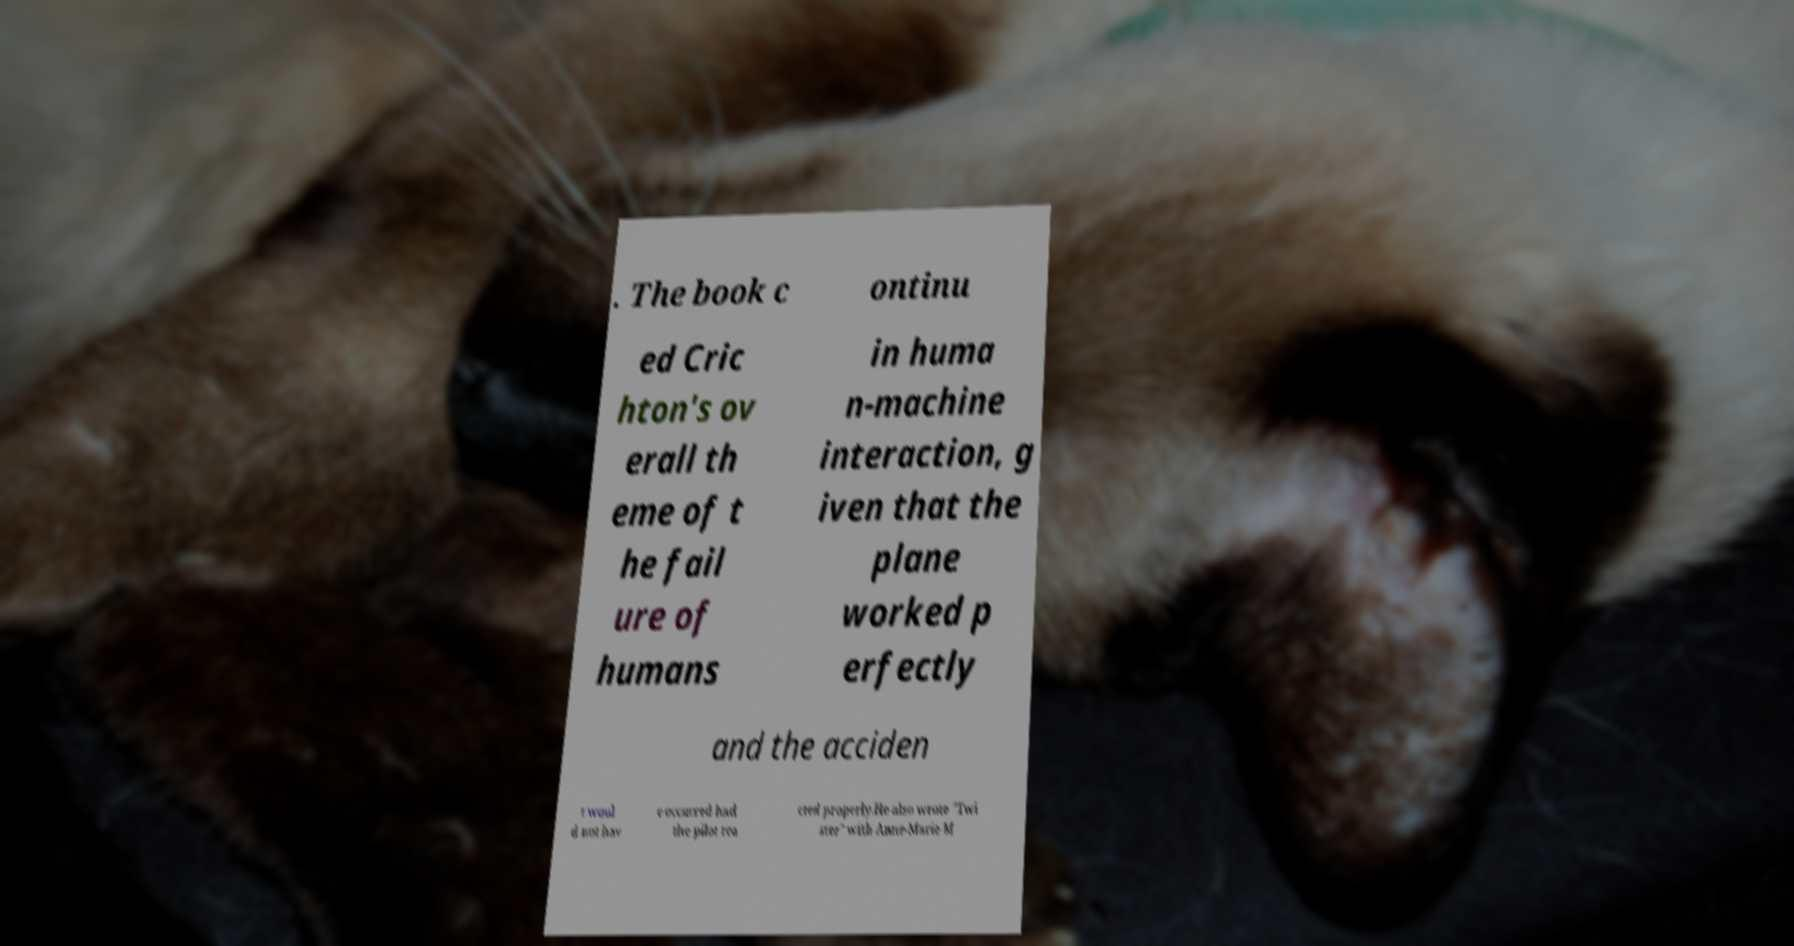For documentation purposes, I need the text within this image transcribed. Could you provide that? . The book c ontinu ed Cric hton's ov erall th eme of t he fail ure of humans in huma n-machine interaction, g iven that the plane worked p erfectly and the acciden t woul d not hav e occurred had the pilot rea cted properly.He also wrote "Twi ster" with Anne-Marie M 